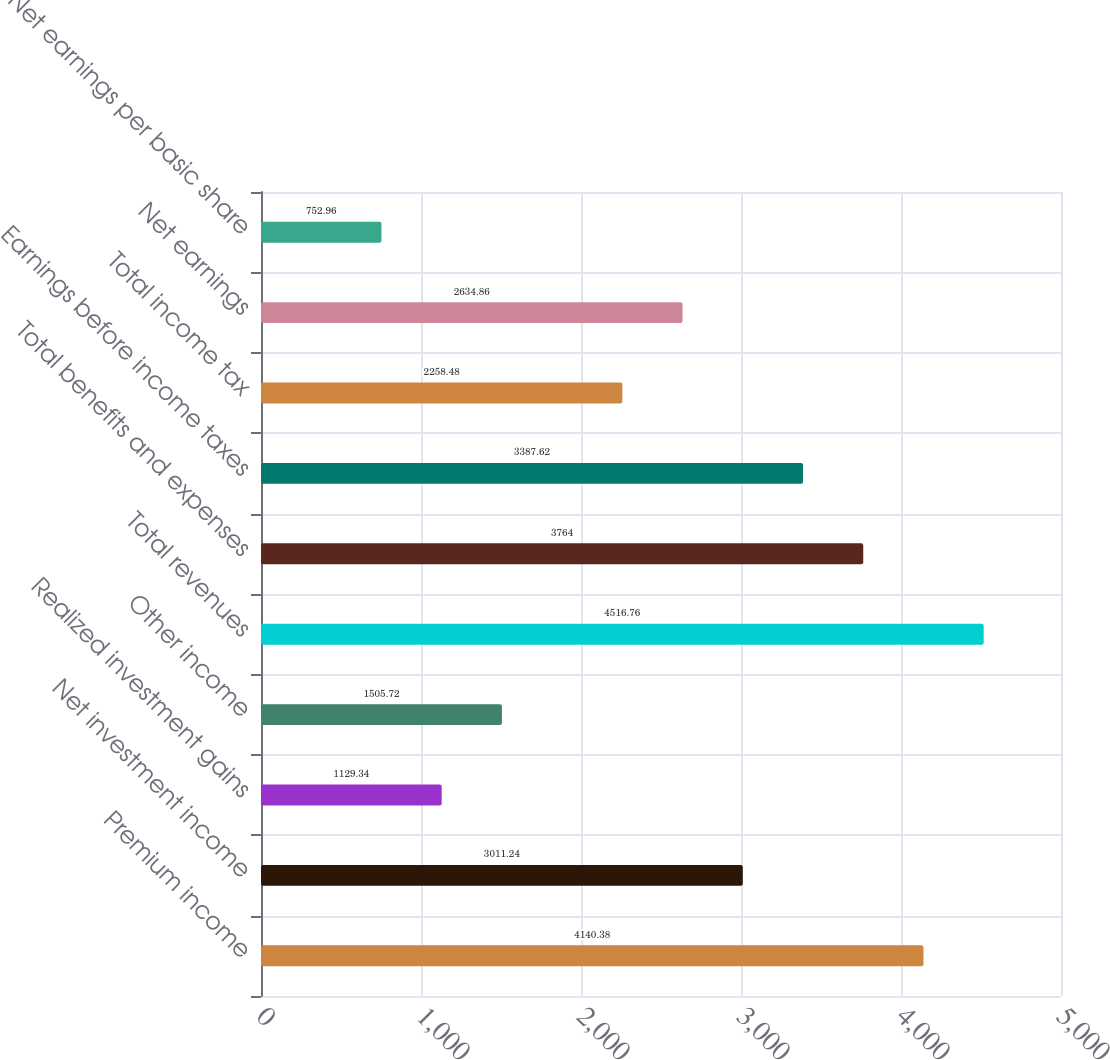Convert chart. <chart><loc_0><loc_0><loc_500><loc_500><bar_chart><fcel>Premium income<fcel>Net investment income<fcel>Realized investment gains<fcel>Other income<fcel>Total revenues<fcel>Total benefits and expenses<fcel>Earnings before income taxes<fcel>Total income tax<fcel>Net earnings<fcel>Net earnings per basic share<nl><fcel>4140.38<fcel>3011.24<fcel>1129.34<fcel>1505.72<fcel>4516.76<fcel>3764<fcel>3387.62<fcel>2258.48<fcel>2634.86<fcel>752.96<nl></chart> 